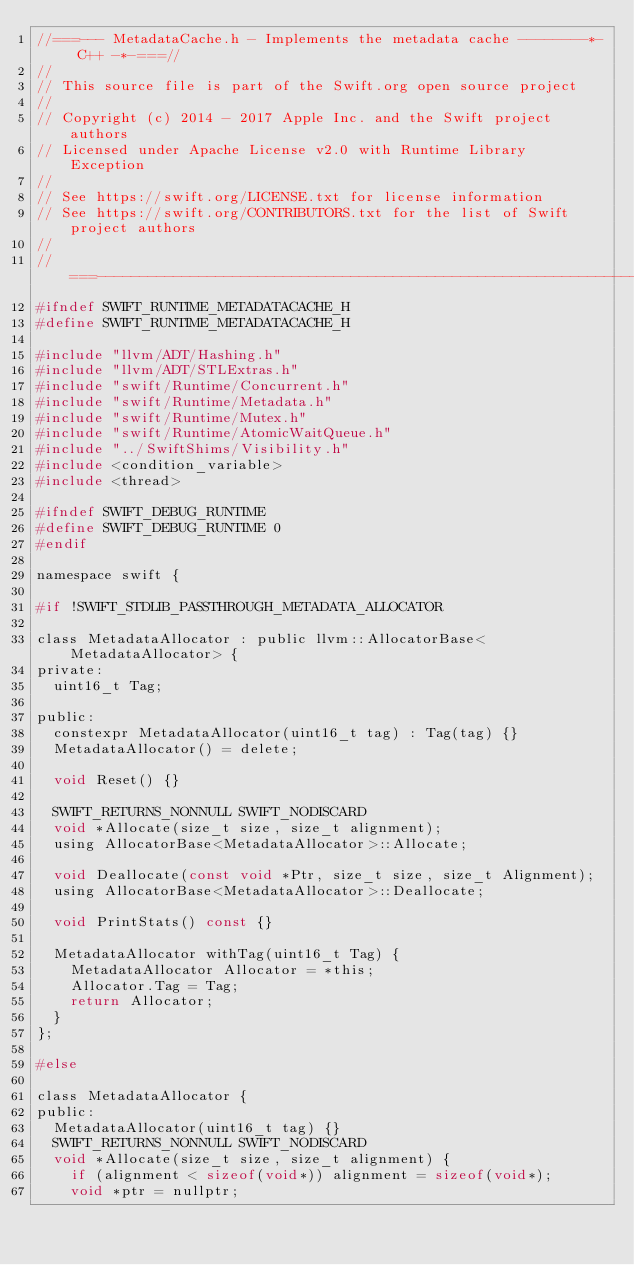Convert code to text. <code><loc_0><loc_0><loc_500><loc_500><_C_>//===--- MetadataCache.h - Implements the metadata cache --------*- C++ -*-===//
//
// This source file is part of the Swift.org open source project
//
// Copyright (c) 2014 - 2017 Apple Inc. and the Swift project authors
// Licensed under Apache License v2.0 with Runtime Library Exception
//
// See https://swift.org/LICENSE.txt for license information
// See https://swift.org/CONTRIBUTORS.txt for the list of Swift project authors
//
//===----------------------------------------------------------------------===//
#ifndef SWIFT_RUNTIME_METADATACACHE_H
#define SWIFT_RUNTIME_METADATACACHE_H

#include "llvm/ADT/Hashing.h"
#include "llvm/ADT/STLExtras.h"
#include "swift/Runtime/Concurrent.h"
#include "swift/Runtime/Metadata.h"
#include "swift/Runtime/Mutex.h"
#include "swift/Runtime/AtomicWaitQueue.h"
#include "../SwiftShims/Visibility.h"
#include <condition_variable>
#include <thread>

#ifndef SWIFT_DEBUG_RUNTIME
#define SWIFT_DEBUG_RUNTIME 0
#endif

namespace swift {

#if !SWIFT_STDLIB_PASSTHROUGH_METADATA_ALLOCATOR

class MetadataAllocator : public llvm::AllocatorBase<MetadataAllocator> {
private:
  uint16_t Tag;

public:
  constexpr MetadataAllocator(uint16_t tag) : Tag(tag) {}
  MetadataAllocator() = delete;

  void Reset() {}

  SWIFT_RETURNS_NONNULL SWIFT_NODISCARD
  void *Allocate(size_t size, size_t alignment);
  using AllocatorBase<MetadataAllocator>::Allocate;

  void Deallocate(const void *Ptr, size_t size, size_t Alignment);
  using AllocatorBase<MetadataAllocator>::Deallocate;

  void PrintStats() const {}
  
  MetadataAllocator withTag(uint16_t Tag) {
    MetadataAllocator Allocator = *this;
    Allocator.Tag = Tag;
    return Allocator;
  }
};

#else

class MetadataAllocator {
public:
  MetadataAllocator(uint16_t tag) {}
  SWIFT_RETURNS_NONNULL SWIFT_NODISCARD
  void *Allocate(size_t size, size_t alignment) {
    if (alignment < sizeof(void*)) alignment = sizeof(void*);
    void *ptr = nullptr;</code> 